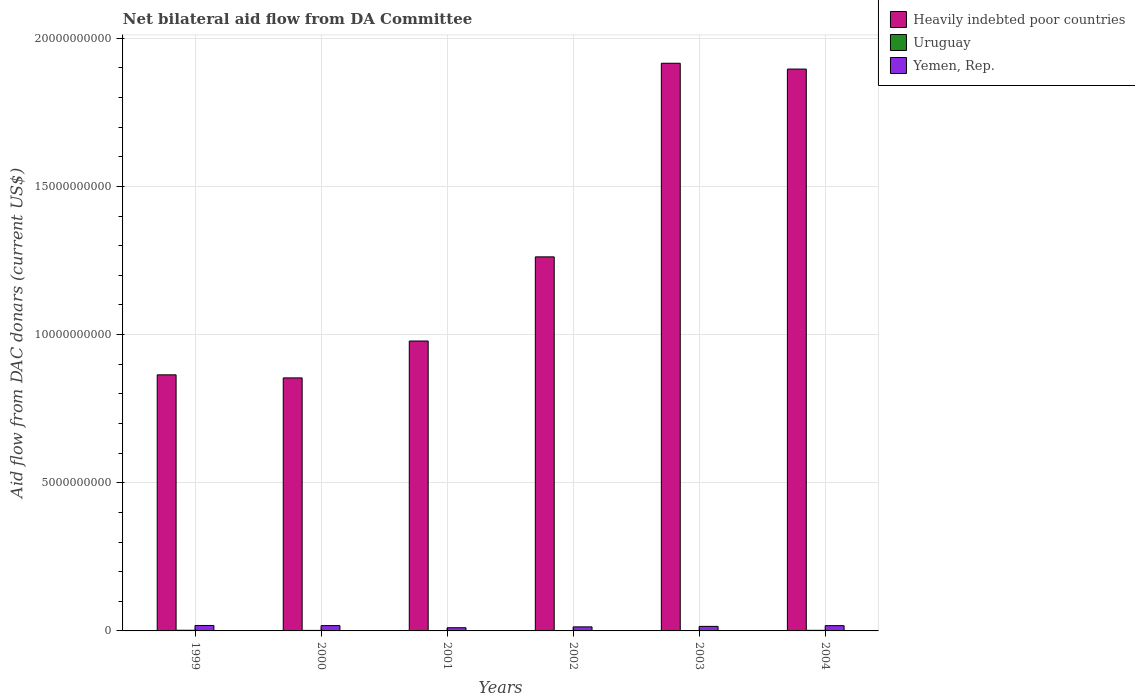Are the number of bars per tick equal to the number of legend labels?
Offer a very short reply. Yes. Are the number of bars on each tick of the X-axis equal?
Provide a short and direct response. Yes. How many bars are there on the 6th tick from the left?
Your answer should be compact. 3. What is the label of the 1st group of bars from the left?
Provide a short and direct response. 1999. In how many cases, is the number of bars for a given year not equal to the number of legend labels?
Give a very brief answer. 0. What is the aid flow in in Heavily indebted poor countries in 1999?
Your response must be concise. 8.64e+09. Across all years, what is the maximum aid flow in in Uruguay?
Keep it short and to the point. 2.26e+07. Across all years, what is the minimum aid flow in in Yemen, Rep.?
Keep it short and to the point. 1.08e+08. In which year was the aid flow in in Heavily indebted poor countries maximum?
Offer a very short reply. 2003. In which year was the aid flow in in Yemen, Rep. minimum?
Provide a short and direct response. 2001. What is the total aid flow in in Uruguay in the graph?
Your response must be concise. 9.56e+07. What is the difference between the aid flow in in Yemen, Rep. in 1999 and that in 2003?
Provide a succinct answer. 3.07e+07. What is the difference between the aid flow in in Yemen, Rep. in 2000 and the aid flow in in Uruguay in 1999?
Provide a short and direct response. 1.56e+08. What is the average aid flow in in Heavily indebted poor countries per year?
Offer a very short reply. 1.29e+1. In the year 1999, what is the difference between the aid flow in in Yemen, Rep. and aid flow in in Heavily indebted poor countries?
Your answer should be very brief. -8.46e+09. In how many years, is the aid flow in in Heavily indebted poor countries greater than 11000000000 US$?
Give a very brief answer. 3. What is the ratio of the aid flow in in Yemen, Rep. in 2001 to that in 2004?
Provide a short and direct response. 0.61. Is the aid flow in in Yemen, Rep. in 2001 less than that in 2002?
Provide a short and direct response. Yes. Is the difference between the aid flow in in Yemen, Rep. in 1999 and 2003 greater than the difference between the aid flow in in Heavily indebted poor countries in 1999 and 2003?
Your response must be concise. Yes. What is the difference between the highest and the second highest aid flow in in Yemen, Rep.?
Give a very brief answer. 4.84e+06. What is the difference between the highest and the lowest aid flow in in Yemen, Rep.?
Keep it short and to the point. 7.60e+07. In how many years, is the aid flow in in Heavily indebted poor countries greater than the average aid flow in in Heavily indebted poor countries taken over all years?
Keep it short and to the point. 2. Is the sum of the aid flow in in Yemen, Rep. in 2000 and 2004 greater than the maximum aid flow in in Uruguay across all years?
Your answer should be compact. Yes. What does the 1st bar from the left in 2001 represents?
Offer a very short reply. Heavily indebted poor countries. What does the 2nd bar from the right in 2000 represents?
Offer a very short reply. Uruguay. Is it the case that in every year, the sum of the aid flow in in Yemen, Rep. and aid flow in in Uruguay is greater than the aid flow in in Heavily indebted poor countries?
Give a very brief answer. No. Are all the bars in the graph horizontal?
Make the answer very short. No. How many years are there in the graph?
Give a very brief answer. 6. What is the title of the graph?
Offer a very short reply. Net bilateral aid flow from DA Committee. What is the label or title of the X-axis?
Provide a short and direct response. Years. What is the label or title of the Y-axis?
Offer a terse response. Aid flow from DAC donars (current US$). What is the Aid flow from DAC donars (current US$) in Heavily indebted poor countries in 1999?
Your response must be concise. 8.64e+09. What is the Aid flow from DAC donars (current US$) of Uruguay in 1999?
Keep it short and to the point. 2.26e+07. What is the Aid flow from DAC donars (current US$) in Yemen, Rep. in 1999?
Make the answer very short. 1.84e+08. What is the Aid flow from DAC donars (current US$) of Heavily indebted poor countries in 2000?
Offer a terse response. 8.54e+09. What is the Aid flow from DAC donars (current US$) of Uruguay in 2000?
Provide a succinct answer. 1.78e+07. What is the Aid flow from DAC donars (current US$) of Yemen, Rep. in 2000?
Keep it short and to the point. 1.79e+08. What is the Aid flow from DAC donars (current US$) of Heavily indebted poor countries in 2001?
Offer a very short reply. 9.78e+09. What is the Aid flow from DAC donars (current US$) of Uruguay in 2001?
Keep it short and to the point. 1.27e+07. What is the Aid flow from DAC donars (current US$) of Yemen, Rep. in 2001?
Provide a succinct answer. 1.08e+08. What is the Aid flow from DAC donars (current US$) of Heavily indebted poor countries in 2002?
Your answer should be compact. 1.26e+1. What is the Aid flow from DAC donars (current US$) in Uruguay in 2002?
Provide a succinct answer. 9.57e+06. What is the Aid flow from DAC donars (current US$) of Yemen, Rep. in 2002?
Ensure brevity in your answer.  1.37e+08. What is the Aid flow from DAC donars (current US$) of Heavily indebted poor countries in 2003?
Make the answer very short. 1.92e+1. What is the Aid flow from DAC donars (current US$) in Uruguay in 2003?
Offer a terse response. 1.26e+07. What is the Aid flow from DAC donars (current US$) in Yemen, Rep. in 2003?
Provide a short and direct response. 1.53e+08. What is the Aid flow from DAC donars (current US$) in Heavily indebted poor countries in 2004?
Ensure brevity in your answer.  1.90e+1. What is the Aid flow from DAC donars (current US$) in Uruguay in 2004?
Give a very brief answer. 2.03e+07. What is the Aid flow from DAC donars (current US$) in Yemen, Rep. in 2004?
Your answer should be very brief. 1.78e+08. Across all years, what is the maximum Aid flow from DAC donars (current US$) in Heavily indebted poor countries?
Your answer should be compact. 1.92e+1. Across all years, what is the maximum Aid flow from DAC donars (current US$) of Uruguay?
Ensure brevity in your answer.  2.26e+07. Across all years, what is the maximum Aid flow from DAC donars (current US$) in Yemen, Rep.?
Your response must be concise. 1.84e+08. Across all years, what is the minimum Aid flow from DAC donars (current US$) of Heavily indebted poor countries?
Provide a succinct answer. 8.54e+09. Across all years, what is the minimum Aid flow from DAC donars (current US$) in Uruguay?
Your response must be concise. 9.57e+06. Across all years, what is the minimum Aid flow from DAC donars (current US$) in Yemen, Rep.?
Your answer should be compact. 1.08e+08. What is the total Aid flow from DAC donars (current US$) of Heavily indebted poor countries in the graph?
Offer a terse response. 7.77e+1. What is the total Aid flow from DAC donars (current US$) in Uruguay in the graph?
Keep it short and to the point. 9.56e+07. What is the total Aid flow from DAC donars (current US$) of Yemen, Rep. in the graph?
Offer a terse response. 9.38e+08. What is the difference between the Aid flow from DAC donars (current US$) in Heavily indebted poor countries in 1999 and that in 2000?
Offer a very short reply. 1.03e+08. What is the difference between the Aid flow from DAC donars (current US$) of Uruguay in 1999 and that in 2000?
Your answer should be compact. 4.78e+06. What is the difference between the Aid flow from DAC donars (current US$) in Yemen, Rep. in 1999 and that in 2000?
Keep it short and to the point. 4.84e+06. What is the difference between the Aid flow from DAC donars (current US$) in Heavily indebted poor countries in 1999 and that in 2001?
Your answer should be compact. -1.14e+09. What is the difference between the Aid flow from DAC donars (current US$) in Uruguay in 1999 and that in 2001?
Give a very brief answer. 9.90e+06. What is the difference between the Aid flow from DAC donars (current US$) of Yemen, Rep. in 1999 and that in 2001?
Provide a succinct answer. 7.60e+07. What is the difference between the Aid flow from DAC donars (current US$) in Heavily indebted poor countries in 1999 and that in 2002?
Give a very brief answer. -3.98e+09. What is the difference between the Aid flow from DAC donars (current US$) of Uruguay in 1999 and that in 2002?
Provide a short and direct response. 1.30e+07. What is the difference between the Aid flow from DAC donars (current US$) of Yemen, Rep. in 1999 and that in 2002?
Provide a succinct answer. 4.68e+07. What is the difference between the Aid flow from DAC donars (current US$) of Heavily indebted poor countries in 1999 and that in 2003?
Your response must be concise. -1.05e+1. What is the difference between the Aid flow from DAC donars (current US$) of Uruguay in 1999 and that in 2003?
Give a very brief answer. 1.00e+07. What is the difference between the Aid flow from DAC donars (current US$) in Yemen, Rep. in 1999 and that in 2003?
Provide a short and direct response. 3.07e+07. What is the difference between the Aid flow from DAC donars (current US$) in Heavily indebted poor countries in 1999 and that in 2004?
Keep it short and to the point. -1.03e+1. What is the difference between the Aid flow from DAC donars (current US$) of Uruguay in 1999 and that in 2004?
Ensure brevity in your answer.  2.31e+06. What is the difference between the Aid flow from DAC donars (current US$) of Yemen, Rep. in 1999 and that in 2004?
Ensure brevity in your answer.  5.90e+06. What is the difference between the Aid flow from DAC donars (current US$) of Heavily indebted poor countries in 2000 and that in 2001?
Make the answer very short. -1.24e+09. What is the difference between the Aid flow from DAC donars (current US$) in Uruguay in 2000 and that in 2001?
Give a very brief answer. 5.12e+06. What is the difference between the Aid flow from DAC donars (current US$) of Yemen, Rep. in 2000 and that in 2001?
Provide a short and direct response. 7.12e+07. What is the difference between the Aid flow from DAC donars (current US$) in Heavily indebted poor countries in 2000 and that in 2002?
Your response must be concise. -4.08e+09. What is the difference between the Aid flow from DAC donars (current US$) of Uruguay in 2000 and that in 2002?
Provide a short and direct response. 8.26e+06. What is the difference between the Aid flow from DAC donars (current US$) of Yemen, Rep. in 2000 and that in 2002?
Make the answer very short. 4.19e+07. What is the difference between the Aid flow from DAC donars (current US$) in Heavily indebted poor countries in 2000 and that in 2003?
Keep it short and to the point. -1.06e+1. What is the difference between the Aid flow from DAC donars (current US$) of Uruguay in 2000 and that in 2003?
Offer a terse response. 5.25e+06. What is the difference between the Aid flow from DAC donars (current US$) of Yemen, Rep. in 2000 and that in 2003?
Provide a succinct answer. 2.58e+07. What is the difference between the Aid flow from DAC donars (current US$) in Heavily indebted poor countries in 2000 and that in 2004?
Keep it short and to the point. -1.04e+1. What is the difference between the Aid flow from DAC donars (current US$) in Uruguay in 2000 and that in 2004?
Ensure brevity in your answer.  -2.47e+06. What is the difference between the Aid flow from DAC donars (current US$) of Yemen, Rep. in 2000 and that in 2004?
Your answer should be very brief. 1.06e+06. What is the difference between the Aid flow from DAC donars (current US$) in Heavily indebted poor countries in 2001 and that in 2002?
Your response must be concise. -2.84e+09. What is the difference between the Aid flow from DAC donars (current US$) in Uruguay in 2001 and that in 2002?
Offer a terse response. 3.14e+06. What is the difference between the Aid flow from DAC donars (current US$) of Yemen, Rep. in 2001 and that in 2002?
Your response must be concise. -2.93e+07. What is the difference between the Aid flow from DAC donars (current US$) of Heavily indebted poor countries in 2001 and that in 2003?
Make the answer very short. -9.37e+09. What is the difference between the Aid flow from DAC donars (current US$) in Uruguay in 2001 and that in 2003?
Make the answer very short. 1.30e+05. What is the difference between the Aid flow from DAC donars (current US$) in Yemen, Rep. in 2001 and that in 2003?
Provide a succinct answer. -4.54e+07. What is the difference between the Aid flow from DAC donars (current US$) of Heavily indebted poor countries in 2001 and that in 2004?
Your response must be concise. -9.18e+09. What is the difference between the Aid flow from DAC donars (current US$) of Uruguay in 2001 and that in 2004?
Your answer should be very brief. -7.59e+06. What is the difference between the Aid flow from DAC donars (current US$) in Yemen, Rep. in 2001 and that in 2004?
Your answer should be compact. -7.02e+07. What is the difference between the Aid flow from DAC donars (current US$) of Heavily indebted poor countries in 2002 and that in 2003?
Your answer should be compact. -6.53e+09. What is the difference between the Aid flow from DAC donars (current US$) of Uruguay in 2002 and that in 2003?
Your response must be concise. -3.01e+06. What is the difference between the Aid flow from DAC donars (current US$) of Yemen, Rep. in 2002 and that in 2003?
Keep it short and to the point. -1.61e+07. What is the difference between the Aid flow from DAC donars (current US$) of Heavily indebted poor countries in 2002 and that in 2004?
Provide a succinct answer. -6.34e+09. What is the difference between the Aid flow from DAC donars (current US$) of Uruguay in 2002 and that in 2004?
Your answer should be very brief. -1.07e+07. What is the difference between the Aid flow from DAC donars (current US$) in Yemen, Rep. in 2002 and that in 2004?
Keep it short and to the point. -4.09e+07. What is the difference between the Aid flow from DAC donars (current US$) in Heavily indebted poor countries in 2003 and that in 2004?
Offer a terse response. 1.96e+08. What is the difference between the Aid flow from DAC donars (current US$) in Uruguay in 2003 and that in 2004?
Offer a terse response. -7.72e+06. What is the difference between the Aid flow from DAC donars (current US$) of Yemen, Rep. in 2003 and that in 2004?
Offer a very short reply. -2.48e+07. What is the difference between the Aid flow from DAC donars (current US$) of Heavily indebted poor countries in 1999 and the Aid flow from DAC donars (current US$) of Uruguay in 2000?
Provide a short and direct response. 8.62e+09. What is the difference between the Aid flow from DAC donars (current US$) of Heavily indebted poor countries in 1999 and the Aid flow from DAC donars (current US$) of Yemen, Rep. in 2000?
Provide a succinct answer. 8.46e+09. What is the difference between the Aid flow from DAC donars (current US$) of Uruguay in 1999 and the Aid flow from DAC donars (current US$) of Yemen, Rep. in 2000?
Your answer should be compact. -1.56e+08. What is the difference between the Aid flow from DAC donars (current US$) in Heavily indebted poor countries in 1999 and the Aid flow from DAC donars (current US$) in Uruguay in 2001?
Keep it short and to the point. 8.63e+09. What is the difference between the Aid flow from DAC donars (current US$) of Heavily indebted poor countries in 1999 and the Aid flow from DAC donars (current US$) of Yemen, Rep. in 2001?
Keep it short and to the point. 8.53e+09. What is the difference between the Aid flow from DAC donars (current US$) of Uruguay in 1999 and the Aid flow from DAC donars (current US$) of Yemen, Rep. in 2001?
Your answer should be compact. -8.50e+07. What is the difference between the Aid flow from DAC donars (current US$) in Heavily indebted poor countries in 1999 and the Aid flow from DAC donars (current US$) in Uruguay in 2002?
Make the answer very short. 8.63e+09. What is the difference between the Aid flow from DAC donars (current US$) of Heavily indebted poor countries in 1999 and the Aid flow from DAC donars (current US$) of Yemen, Rep. in 2002?
Your answer should be very brief. 8.50e+09. What is the difference between the Aid flow from DAC donars (current US$) of Uruguay in 1999 and the Aid flow from DAC donars (current US$) of Yemen, Rep. in 2002?
Your response must be concise. -1.14e+08. What is the difference between the Aid flow from DAC donars (current US$) of Heavily indebted poor countries in 1999 and the Aid flow from DAC donars (current US$) of Uruguay in 2003?
Your answer should be compact. 8.63e+09. What is the difference between the Aid flow from DAC donars (current US$) of Heavily indebted poor countries in 1999 and the Aid flow from DAC donars (current US$) of Yemen, Rep. in 2003?
Keep it short and to the point. 8.49e+09. What is the difference between the Aid flow from DAC donars (current US$) in Uruguay in 1999 and the Aid flow from DAC donars (current US$) in Yemen, Rep. in 2003?
Offer a terse response. -1.30e+08. What is the difference between the Aid flow from DAC donars (current US$) of Heavily indebted poor countries in 1999 and the Aid flow from DAC donars (current US$) of Uruguay in 2004?
Your response must be concise. 8.62e+09. What is the difference between the Aid flow from DAC donars (current US$) of Heavily indebted poor countries in 1999 and the Aid flow from DAC donars (current US$) of Yemen, Rep. in 2004?
Give a very brief answer. 8.46e+09. What is the difference between the Aid flow from DAC donars (current US$) of Uruguay in 1999 and the Aid flow from DAC donars (current US$) of Yemen, Rep. in 2004?
Your answer should be very brief. -1.55e+08. What is the difference between the Aid flow from DAC donars (current US$) of Heavily indebted poor countries in 2000 and the Aid flow from DAC donars (current US$) of Uruguay in 2001?
Make the answer very short. 8.53e+09. What is the difference between the Aid flow from DAC donars (current US$) of Heavily indebted poor countries in 2000 and the Aid flow from DAC donars (current US$) of Yemen, Rep. in 2001?
Your response must be concise. 8.43e+09. What is the difference between the Aid flow from DAC donars (current US$) in Uruguay in 2000 and the Aid flow from DAC donars (current US$) in Yemen, Rep. in 2001?
Give a very brief answer. -8.98e+07. What is the difference between the Aid flow from DAC donars (current US$) of Heavily indebted poor countries in 2000 and the Aid flow from DAC donars (current US$) of Uruguay in 2002?
Offer a very short reply. 8.53e+09. What is the difference between the Aid flow from DAC donars (current US$) of Heavily indebted poor countries in 2000 and the Aid flow from DAC donars (current US$) of Yemen, Rep. in 2002?
Provide a succinct answer. 8.40e+09. What is the difference between the Aid flow from DAC donars (current US$) in Uruguay in 2000 and the Aid flow from DAC donars (current US$) in Yemen, Rep. in 2002?
Make the answer very short. -1.19e+08. What is the difference between the Aid flow from DAC donars (current US$) in Heavily indebted poor countries in 2000 and the Aid flow from DAC donars (current US$) in Uruguay in 2003?
Provide a short and direct response. 8.53e+09. What is the difference between the Aid flow from DAC donars (current US$) of Heavily indebted poor countries in 2000 and the Aid flow from DAC donars (current US$) of Yemen, Rep. in 2003?
Provide a short and direct response. 8.38e+09. What is the difference between the Aid flow from DAC donars (current US$) in Uruguay in 2000 and the Aid flow from DAC donars (current US$) in Yemen, Rep. in 2003?
Offer a very short reply. -1.35e+08. What is the difference between the Aid flow from DAC donars (current US$) in Heavily indebted poor countries in 2000 and the Aid flow from DAC donars (current US$) in Uruguay in 2004?
Your response must be concise. 8.52e+09. What is the difference between the Aid flow from DAC donars (current US$) of Heavily indebted poor countries in 2000 and the Aid flow from DAC donars (current US$) of Yemen, Rep. in 2004?
Ensure brevity in your answer.  8.36e+09. What is the difference between the Aid flow from DAC donars (current US$) of Uruguay in 2000 and the Aid flow from DAC donars (current US$) of Yemen, Rep. in 2004?
Offer a very short reply. -1.60e+08. What is the difference between the Aid flow from DAC donars (current US$) in Heavily indebted poor countries in 2001 and the Aid flow from DAC donars (current US$) in Uruguay in 2002?
Provide a succinct answer. 9.77e+09. What is the difference between the Aid flow from DAC donars (current US$) in Heavily indebted poor countries in 2001 and the Aid flow from DAC donars (current US$) in Yemen, Rep. in 2002?
Keep it short and to the point. 9.65e+09. What is the difference between the Aid flow from DAC donars (current US$) in Uruguay in 2001 and the Aid flow from DAC donars (current US$) in Yemen, Rep. in 2002?
Provide a succinct answer. -1.24e+08. What is the difference between the Aid flow from DAC donars (current US$) in Heavily indebted poor countries in 2001 and the Aid flow from DAC donars (current US$) in Uruguay in 2003?
Provide a short and direct response. 9.77e+09. What is the difference between the Aid flow from DAC donars (current US$) in Heavily indebted poor countries in 2001 and the Aid flow from DAC donars (current US$) in Yemen, Rep. in 2003?
Ensure brevity in your answer.  9.63e+09. What is the difference between the Aid flow from DAC donars (current US$) in Uruguay in 2001 and the Aid flow from DAC donars (current US$) in Yemen, Rep. in 2003?
Make the answer very short. -1.40e+08. What is the difference between the Aid flow from DAC donars (current US$) in Heavily indebted poor countries in 2001 and the Aid flow from DAC donars (current US$) in Uruguay in 2004?
Give a very brief answer. 9.76e+09. What is the difference between the Aid flow from DAC donars (current US$) in Heavily indebted poor countries in 2001 and the Aid flow from DAC donars (current US$) in Yemen, Rep. in 2004?
Your answer should be very brief. 9.60e+09. What is the difference between the Aid flow from DAC donars (current US$) of Uruguay in 2001 and the Aid flow from DAC donars (current US$) of Yemen, Rep. in 2004?
Provide a succinct answer. -1.65e+08. What is the difference between the Aid flow from DAC donars (current US$) of Heavily indebted poor countries in 2002 and the Aid flow from DAC donars (current US$) of Uruguay in 2003?
Ensure brevity in your answer.  1.26e+1. What is the difference between the Aid flow from DAC donars (current US$) in Heavily indebted poor countries in 2002 and the Aid flow from DAC donars (current US$) in Yemen, Rep. in 2003?
Make the answer very short. 1.25e+1. What is the difference between the Aid flow from DAC donars (current US$) in Uruguay in 2002 and the Aid flow from DAC donars (current US$) in Yemen, Rep. in 2003?
Offer a terse response. -1.43e+08. What is the difference between the Aid flow from DAC donars (current US$) of Heavily indebted poor countries in 2002 and the Aid flow from DAC donars (current US$) of Uruguay in 2004?
Your answer should be compact. 1.26e+1. What is the difference between the Aid flow from DAC donars (current US$) in Heavily indebted poor countries in 2002 and the Aid flow from DAC donars (current US$) in Yemen, Rep. in 2004?
Give a very brief answer. 1.24e+1. What is the difference between the Aid flow from DAC donars (current US$) in Uruguay in 2002 and the Aid flow from DAC donars (current US$) in Yemen, Rep. in 2004?
Give a very brief answer. -1.68e+08. What is the difference between the Aid flow from DAC donars (current US$) of Heavily indebted poor countries in 2003 and the Aid flow from DAC donars (current US$) of Uruguay in 2004?
Ensure brevity in your answer.  1.91e+1. What is the difference between the Aid flow from DAC donars (current US$) of Heavily indebted poor countries in 2003 and the Aid flow from DAC donars (current US$) of Yemen, Rep. in 2004?
Offer a very short reply. 1.90e+1. What is the difference between the Aid flow from DAC donars (current US$) in Uruguay in 2003 and the Aid flow from DAC donars (current US$) in Yemen, Rep. in 2004?
Give a very brief answer. -1.65e+08. What is the average Aid flow from DAC donars (current US$) in Heavily indebted poor countries per year?
Keep it short and to the point. 1.29e+1. What is the average Aid flow from DAC donars (current US$) of Uruguay per year?
Your answer should be compact. 1.59e+07. What is the average Aid flow from DAC donars (current US$) in Yemen, Rep. per year?
Your answer should be compact. 1.56e+08. In the year 1999, what is the difference between the Aid flow from DAC donars (current US$) in Heavily indebted poor countries and Aid flow from DAC donars (current US$) in Uruguay?
Make the answer very short. 8.62e+09. In the year 1999, what is the difference between the Aid flow from DAC donars (current US$) of Heavily indebted poor countries and Aid flow from DAC donars (current US$) of Yemen, Rep.?
Offer a terse response. 8.46e+09. In the year 1999, what is the difference between the Aid flow from DAC donars (current US$) in Uruguay and Aid flow from DAC donars (current US$) in Yemen, Rep.?
Offer a terse response. -1.61e+08. In the year 2000, what is the difference between the Aid flow from DAC donars (current US$) of Heavily indebted poor countries and Aid flow from DAC donars (current US$) of Uruguay?
Offer a very short reply. 8.52e+09. In the year 2000, what is the difference between the Aid flow from DAC donars (current US$) in Heavily indebted poor countries and Aid flow from DAC donars (current US$) in Yemen, Rep.?
Provide a succinct answer. 8.36e+09. In the year 2000, what is the difference between the Aid flow from DAC donars (current US$) in Uruguay and Aid flow from DAC donars (current US$) in Yemen, Rep.?
Provide a short and direct response. -1.61e+08. In the year 2001, what is the difference between the Aid flow from DAC donars (current US$) of Heavily indebted poor countries and Aid flow from DAC donars (current US$) of Uruguay?
Provide a short and direct response. 9.77e+09. In the year 2001, what is the difference between the Aid flow from DAC donars (current US$) of Heavily indebted poor countries and Aid flow from DAC donars (current US$) of Yemen, Rep.?
Give a very brief answer. 9.67e+09. In the year 2001, what is the difference between the Aid flow from DAC donars (current US$) of Uruguay and Aid flow from DAC donars (current US$) of Yemen, Rep.?
Your response must be concise. -9.49e+07. In the year 2002, what is the difference between the Aid flow from DAC donars (current US$) of Heavily indebted poor countries and Aid flow from DAC donars (current US$) of Uruguay?
Your answer should be compact. 1.26e+1. In the year 2002, what is the difference between the Aid flow from DAC donars (current US$) of Heavily indebted poor countries and Aid flow from DAC donars (current US$) of Yemen, Rep.?
Ensure brevity in your answer.  1.25e+1. In the year 2002, what is the difference between the Aid flow from DAC donars (current US$) in Uruguay and Aid flow from DAC donars (current US$) in Yemen, Rep.?
Your answer should be compact. -1.27e+08. In the year 2003, what is the difference between the Aid flow from DAC donars (current US$) in Heavily indebted poor countries and Aid flow from DAC donars (current US$) in Uruguay?
Your answer should be very brief. 1.91e+1. In the year 2003, what is the difference between the Aid flow from DAC donars (current US$) of Heavily indebted poor countries and Aid flow from DAC donars (current US$) of Yemen, Rep.?
Offer a very short reply. 1.90e+1. In the year 2003, what is the difference between the Aid flow from DAC donars (current US$) in Uruguay and Aid flow from DAC donars (current US$) in Yemen, Rep.?
Make the answer very short. -1.40e+08. In the year 2004, what is the difference between the Aid flow from DAC donars (current US$) in Heavily indebted poor countries and Aid flow from DAC donars (current US$) in Uruguay?
Give a very brief answer. 1.89e+1. In the year 2004, what is the difference between the Aid flow from DAC donars (current US$) of Heavily indebted poor countries and Aid flow from DAC donars (current US$) of Yemen, Rep.?
Provide a short and direct response. 1.88e+1. In the year 2004, what is the difference between the Aid flow from DAC donars (current US$) in Uruguay and Aid flow from DAC donars (current US$) in Yemen, Rep.?
Your answer should be compact. -1.57e+08. What is the ratio of the Aid flow from DAC donars (current US$) of Heavily indebted poor countries in 1999 to that in 2000?
Provide a short and direct response. 1.01. What is the ratio of the Aid flow from DAC donars (current US$) of Uruguay in 1999 to that in 2000?
Your response must be concise. 1.27. What is the ratio of the Aid flow from DAC donars (current US$) of Yemen, Rep. in 1999 to that in 2000?
Offer a very short reply. 1.03. What is the ratio of the Aid flow from DAC donars (current US$) of Heavily indebted poor countries in 1999 to that in 2001?
Your answer should be compact. 0.88. What is the ratio of the Aid flow from DAC donars (current US$) in Uruguay in 1999 to that in 2001?
Keep it short and to the point. 1.78. What is the ratio of the Aid flow from DAC donars (current US$) of Yemen, Rep. in 1999 to that in 2001?
Your answer should be very brief. 1.71. What is the ratio of the Aid flow from DAC donars (current US$) in Heavily indebted poor countries in 1999 to that in 2002?
Offer a terse response. 0.68. What is the ratio of the Aid flow from DAC donars (current US$) in Uruguay in 1999 to that in 2002?
Provide a short and direct response. 2.36. What is the ratio of the Aid flow from DAC donars (current US$) of Yemen, Rep. in 1999 to that in 2002?
Keep it short and to the point. 1.34. What is the ratio of the Aid flow from DAC donars (current US$) of Heavily indebted poor countries in 1999 to that in 2003?
Ensure brevity in your answer.  0.45. What is the ratio of the Aid flow from DAC donars (current US$) of Uruguay in 1999 to that in 2003?
Keep it short and to the point. 1.8. What is the ratio of the Aid flow from DAC donars (current US$) in Yemen, Rep. in 1999 to that in 2003?
Give a very brief answer. 1.2. What is the ratio of the Aid flow from DAC donars (current US$) in Heavily indebted poor countries in 1999 to that in 2004?
Offer a terse response. 0.46. What is the ratio of the Aid flow from DAC donars (current US$) in Uruguay in 1999 to that in 2004?
Your answer should be very brief. 1.11. What is the ratio of the Aid flow from DAC donars (current US$) in Yemen, Rep. in 1999 to that in 2004?
Keep it short and to the point. 1.03. What is the ratio of the Aid flow from DAC donars (current US$) of Heavily indebted poor countries in 2000 to that in 2001?
Provide a short and direct response. 0.87. What is the ratio of the Aid flow from DAC donars (current US$) of Uruguay in 2000 to that in 2001?
Ensure brevity in your answer.  1.4. What is the ratio of the Aid flow from DAC donars (current US$) of Yemen, Rep. in 2000 to that in 2001?
Your answer should be compact. 1.66. What is the ratio of the Aid flow from DAC donars (current US$) of Heavily indebted poor countries in 2000 to that in 2002?
Provide a succinct answer. 0.68. What is the ratio of the Aid flow from DAC donars (current US$) of Uruguay in 2000 to that in 2002?
Make the answer very short. 1.86. What is the ratio of the Aid flow from DAC donars (current US$) in Yemen, Rep. in 2000 to that in 2002?
Your answer should be compact. 1.31. What is the ratio of the Aid flow from DAC donars (current US$) in Heavily indebted poor countries in 2000 to that in 2003?
Offer a very short reply. 0.45. What is the ratio of the Aid flow from DAC donars (current US$) in Uruguay in 2000 to that in 2003?
Provide a short and direct response. 1.42. What is the ratio of the Aid flow from DAC donars (current US$) of Yemen, Rep. in 2000 to that in 2003?
Your answer should be very brief. 1.17. What is the ratio of the Aid flow from DAC donars (current US$) of Heavily indebted poor countries in 2000 to that in 2004?
Your answer should be very brief. 0.45. What is the ratio of the Aid flow from DAC donars (current US$) of Uruguay in 2000 to that in 2004?
Offer a terse response. 0.88. What is the ratio of the Aid flow from DAC donars (current US$) of Yemen, Rep. in 2000 to that in 2004?
Provide a succinct answer. 1.01. What is the ratio of the Aid flow from DAC donars (current US$) in Heavily indebted poor countries in 2001 to that in 2002?
Provide a succinct answer. 0.78. What is the ratio of the Aid flow from DAC donars (current US$) in Uruguay in 2001 to that in 2002?
Keep it short and to the point. 1.33. What is the ratio of the Aid flow from DAC donars (current US$) in Yemen, Rep. in 2001 to that in 2002?
Provide a short and direct response. 0.79. What is the ratio of the Aid flow from DAC donars (current US$) of Heavily indebted poor countries in 2001 to that in 2003?
Provide a short and direct response. 0.51. What is the ratio of the Aid flow from DAC donars (current US$) of Uruguay in 2001 to that in 2003?
Your answer should be compact. 1.01. What is the ratio of the Aid flow from DAC donars (current US$) in Yemen, Rep. in 2001 to that in 2003?
Give a very brief answer. 0.7. What is the ratio of the Aid flow from DAC donars (current US$) in Heavily indebted poor countries in 2001 to that in 2004?
Make the answer very short. 0.52. What is the ratio of the Aid flow from DAC donars (current US$) of Uruguay in 2001 to that in 2004?
Provide a short and direct response. 0.63. What is the ratio of the Aid flow from DAC donars (current US$) in Yemen, Rep. in 2001 to that in 2004?
Provide a succinct answer. 0.61. What is the ratio of the Aid flow from DAC donars (current US$) of Heavily indebted poor countries in 2002 to that in 2003?
Your answer should be compact. 0.66. What is the ratio of the Aid flow from DAC donars (current US$) in Uruguay in 2002 to that in 2003?
Your answer should be compact. 0.76. What is the ratio of the Aid flow from DAC donars (current US$) in Yemen, Rep. in 2002 to that in 2003?
Keep it short and to the point. 0.89. What is the ratio of the Aid flow from DAC donars (current US$) in Heavily indebted poor countries in 2002 to that in 2004?
Your response must be concise. 0.67. What is the ratio of the Aid flow from DAC donars (current US$) of Uruguay in 2002 to that in 2004?
Give a very brief answer. 0.47. What is the ratio of the Aid flow from DAC donars (current US$) in Yemen, Rep. in 2002 to that in 2004?
Make the answer very short. 0.77. What is the ratio of the Aid flow from DAC donars (current US$) in Heavily indebted poor countries in 2003 to that in 2004?
Make the answer very short. 1.01. What is the ratio of the Aid flow from DAC donars (current US$) in Uruguay in 2003 to that in 2004?
Provide a short and direct response. 0.62. What is the ratio of the Aid flow from DAC donars (current US$) of Yemen, Rep. in 2003 to that in 2004?
Provide a short and direct response. 0.86. What is the difference between the highest and the second highest Aid flow from DAC donars (current US$) in Heavily indebted poor countries?
Make the answer very short. 1.96e+08. What is the difference between the highest and the second highest Aid flow from DAC donars (current US$) in Uruguay?
Give a very brief answer. 2.31e+06. What is the difference between the highest and the second highest Aid flow from DAC donars (current US$) of Yemen, Rep.?
Ensure brevity in your answer.  4.84e+06. What is the difference between the highest and the lowest Aid flow from DAC donars (current US$) of Heavily indebted poor countries?
Offer a terse response. 1.06e+1. What is the difference between the highest and the lowest Aid flow from DAC donars (current US$) in Uruguay?
Make the answer very short. 1.30e+07. What is the difference between the highest and the lowest Aid flow from DAC donars (current US$) of Yemen, Rep.?
Give a very brief answer. 7.60e+07. 